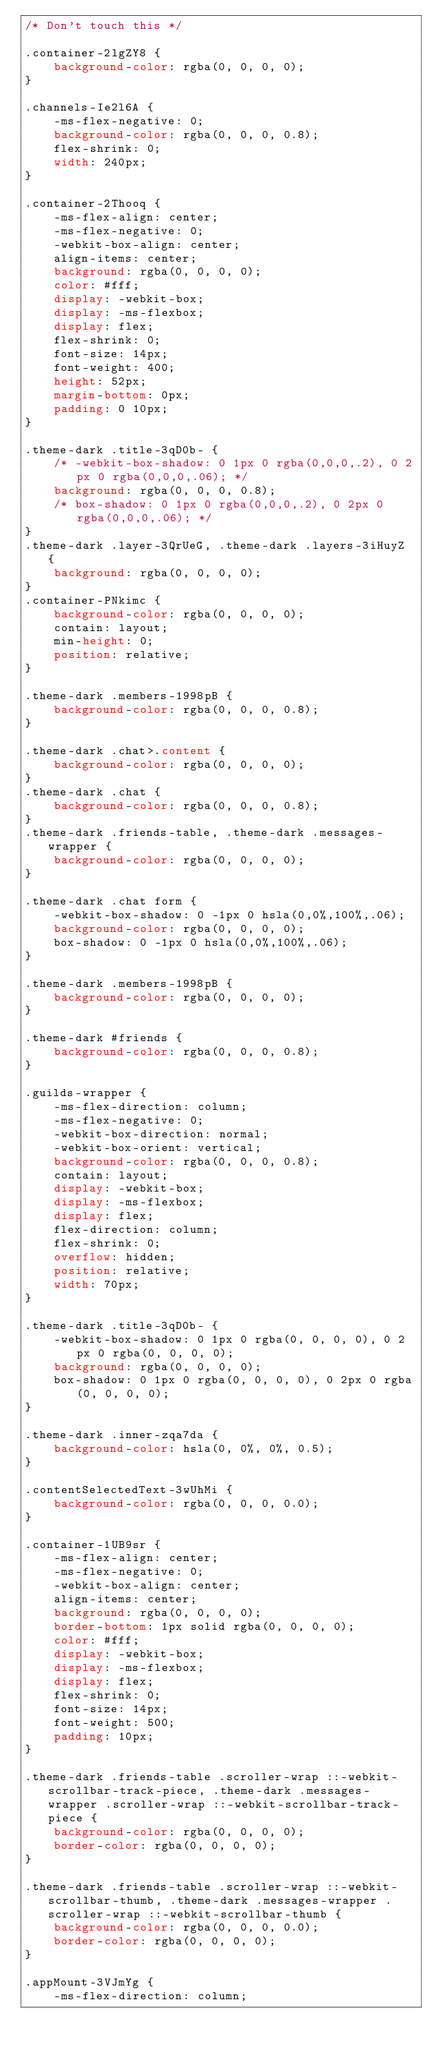<code> <loc_0><loc_0><loc_500><loc_500><_CSS_>/* Don't touch this */

.container-2lgZY8 {
    background-color: rgba(0, 0, 0, 0);
}

.channels-Ie2l6A {
    -ms-flex-negative: 0;
    background-color: rgba(0, 0, 0, 0.8);
    flex-shrink: 0;
    width: 240px;
}

.container-2Thooq {
    -ms-flex-align: center;
    -ms-flex-negative: 0;
    -webkit-box-align: center;
    align-items: center;
    background: rgba(0, 0, 0, 0);
    color: #fff;
    display: -webkit-box;
    display: -ms-flexbox;
    display: flex;
    flex-shrink: 0;
    font-size: 14px;
    font-weight: 400;
    height: 52px;
    margin-bottom: 0px;
    padding: 0 10px;
}

.theme-dark .title-3qD0b- {
    /* -webkit-box-shadow: 0 1px 0 rgba(0,0,0,.2), 0 2px 0 rgba(0,0,0,.06); */
    background: rgba(0, 0, 0, 0.8);
    /* box-shadow: 0 1px 0 rgba(0,0,0,.2), 0 2px 0 rgba(0,0,0,.06); */
}
.theme-dark .layer-3QrUeG, .theme-dark .layers-3iHuyZ {
    background: rgba(0, 0, 0, 0);
}
.container-PNkimc {
    background-color: rgba(0, 0, 0, 0);
    contain: layout;
    min-height: 0;
    position: relative;
}

.theme-dark .members-1998pB {
    background-color: rgba(0, 0, 0, 0.8);
}

.theme-dark .chat>.content {
    background-color: rgba(0, 0, 0, 0);
}
.theme-dark .chat {
    background-color: rgba(0, 0, 0, 0.8);
}
.theme-dark .friends-table, .theme-dark .messages-wrapper {
    background-color: rgba(0, 0, 0, 0);
}

.theme-dark .chat form {
    -webkit-box-shadow: 0 -1px 0 hsla(0,0%,100%,.06);
    background-color: rgba(0, 0, 0, 0);
    box-shadow: 0 -1px 0 hsla(0,0%,100%,.06);
}

.theme-dark .members-1998pB {
    background-color: rgba(0, 0, 0, 0);
}

.theme-dark #friends {
    background-color: rgba(0, 0, 0, 0.8);
}

.guilds-wrapper {
    -ms-flex-direction: column;
    -ms-flex-negative: 0;
    -webkit-box-direction: normal;
    -webkit-box-orient: vertical;
    background-color: rgba(0, 0, 0, 0.8);
    contain: layout;
    display: -webkit-box;
    display: -ms-flexbox;
    display: flex;
    flex-direction: column;
    flex-shrink: 0;
    overflow: hidden;
    position: relative;
    width: 70px;
}

.theme-dark .title-3qD0b- {
    -webkit-box-shadow: 0 1px 0 rgba(0, 0, 0, 0), 0 2px 0 rgba(0, 0, 0, 0);
    background: rgba(0, 0, 0, 0);
    box-shadow: 0 1px 0 rgba(0, 0, 0, 0), 0 2px 0 rgba(0, 0, 0, 0);
}

.theme-dark .inner-zqa7da {
    background-color: hsla(0, 0%, 0%, 0.5);
}

.contentSelectedText-3wUhMi {
    background-color: rgba(0, 0, 0, 0.0);
}

.container-1UB9sr {
    -ms-flex-align: center;
    -ms-flex-negative: 0;
    -webkit-box-align: center;
    align-items: center;
    background: rgba(0, 0, 0, 0);
    border-bottom: 1px solid rgba(0, 0, 0, 0);
    color: #fff;
    display: -webkit-box;
    display: -ms-flexbox;
    display: flex;
    flex-shrink: 0;
    font-size: 14px;
    font-weight: 500;
    padding: 10px;
}

.theme-dark .friends-table .scroller-wrap ::-webkit-scrollbar-track-piece, .theme-dark .messages-wrapper .scroller-wrap ::-webkit-scrollbar-track-piece {
    background-color: rgba(0, 0, 0, 0);
    border-color: rgba(0, 0, 0, 0);
}

.theme-dark .friends-table .scroller-wrap ::-webkit-scrollbar-thumb, .theme-dark .messages-wrapper .scroller-wrap ::-webkit-scrollbar-thumb {
    background-color: rgba(0, 0, 0, 0.0);
    border-color: rgba(0, 0, 0, 0);
}

.appMount-3VJmYg {
    -ms-flex-direction: column;</code> 